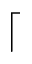<formula> <loc_0><loc_0><loc_500><loc_500>\lceil</formula> 